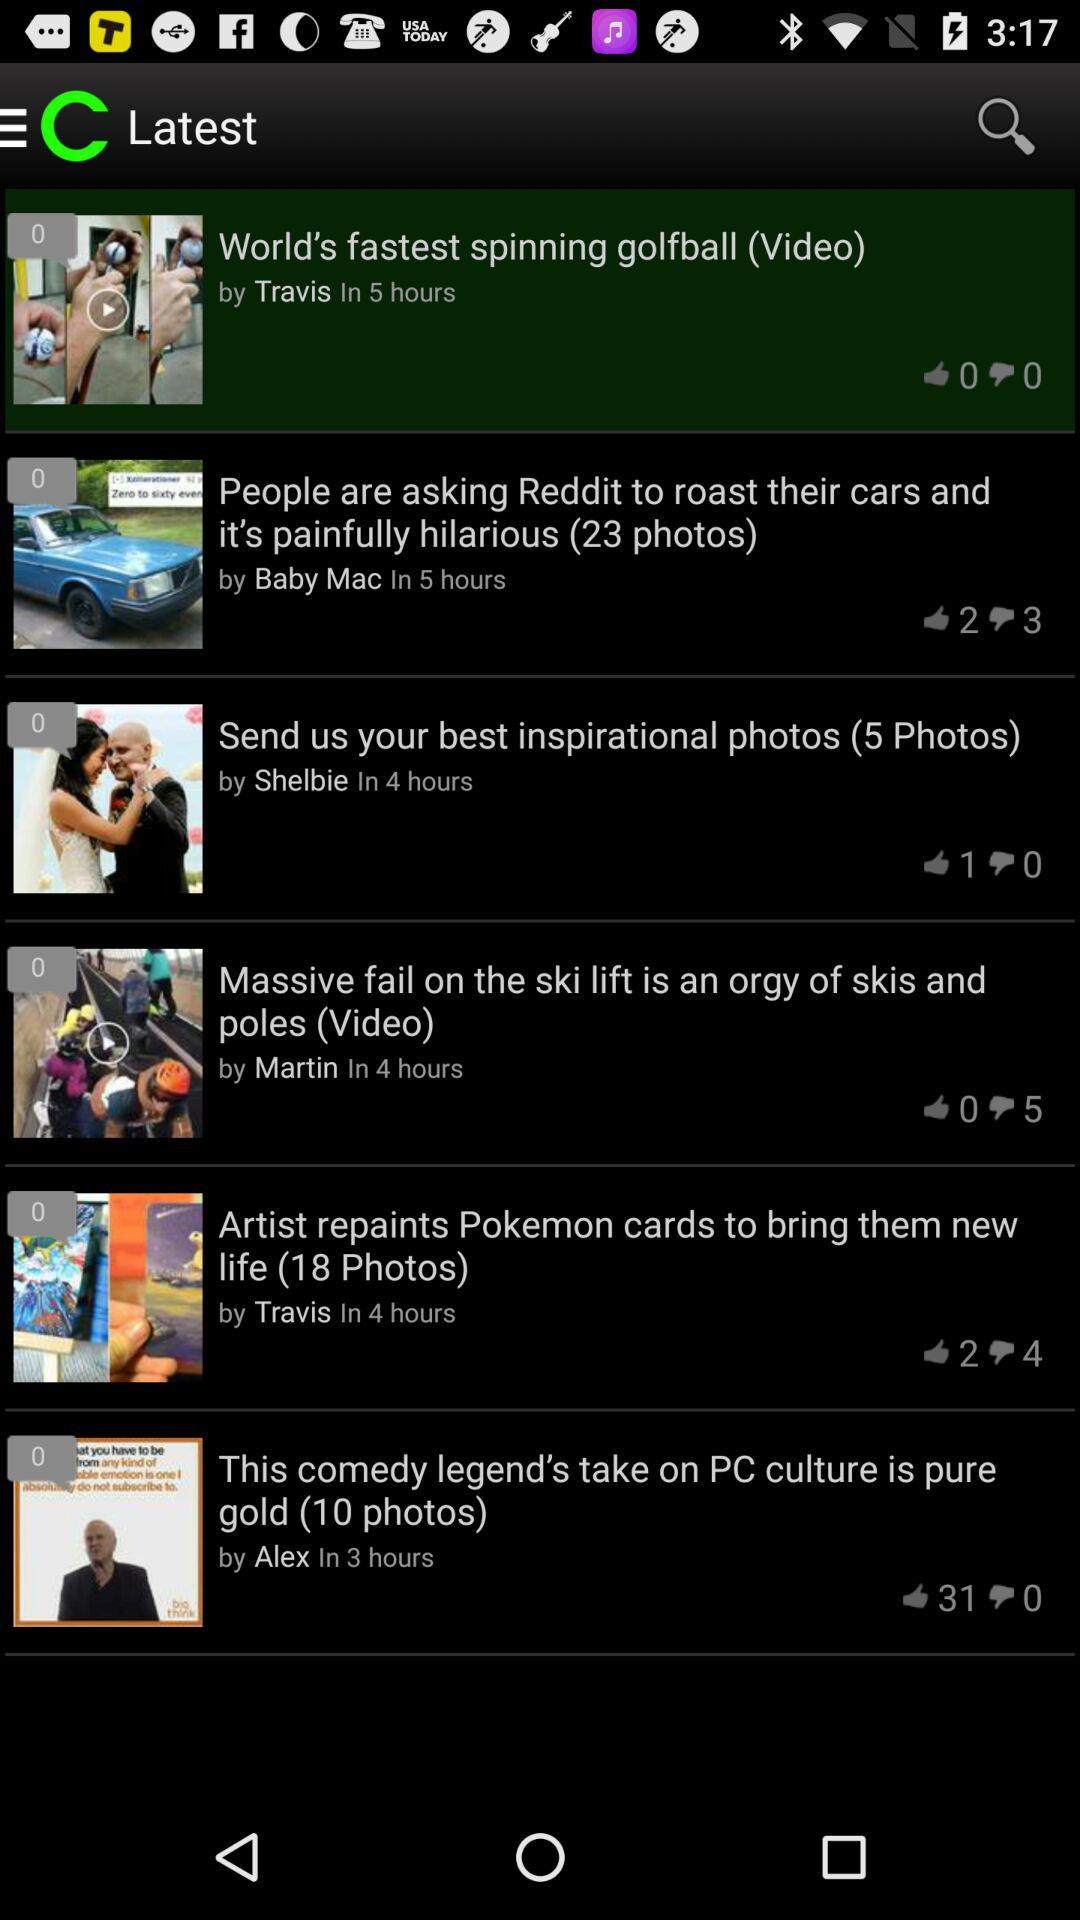What is the app name? The app name is "theCHIVE". 